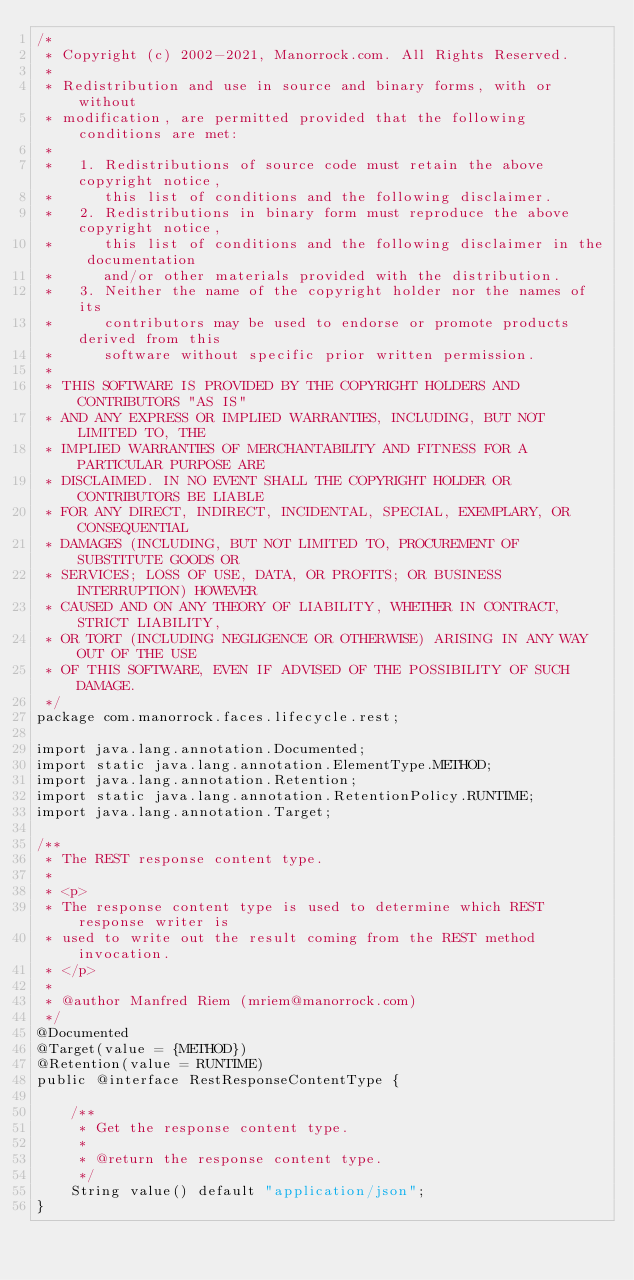<code> <loc_0><loc_0><loc_500><loc_500><_Java_>/*
 * Copyright (c) 2002-2021, Manorrock.com. All Rights Reserved.
 *
 * Redistribution and use in source and binary forms, with or without 
 * modification, are permitted provided that the following conditions are met:
 *
 *   1. Redistributions of source code must retain the above copyright notice, 
 *      this list of conditions and the following disclaimer.
 *   2. Redistributions in binary form must reproduce the above copyright notice,
 *      this list of conditions and the following disclaimer in the documentation
 *      and/or other materials provided with the distribution.
 *   3. Neither the name of the copyright holder nor the names of its 
 *      contributors may be used to endorse or promote products derived from this
 *      software without specific prior written permission.
 *
 * THIS SOFTWARE IS PROVIDED BY THE COPYRIGHT HOLDERS AND CONTRIBUTORS "AS IS" 
 * AND ANY EXPRESS OR IMPLIED WARRANTIES, INCLUDING, BUT NOT LIMITED TO, THE 
 * IMPLIED WARRANTIES OF MERCHANTABILITY AND FITNESS FOR A PARTICULAR PURPOSE ARE
 * DISCLAIMED. IN NO EVENT SHALL THE COPYRIGHT HOLDER OR CONTRIBUTORS BE LIABLE
 * FOR ANY DIRECT, INDIRECT, INCIDENTAL, SPECIAL, EXEMPLARY, OR CONSEQUENTIAL
 * DAMAGES (INCLUDING, BUT NOT LIMITED TO, PROCUREMENT OF SUBSTITUTE GOODS OR
 * SERVICES; LOSS OF USE, DATA, OR PROFITS; OR BUSINESS INTERRUPTION) HOWEVER
 * CAUSED AND ON ANY THEORY OF LIABILITY, WHETHER IN CONTRACT, STRICT LIABILITY,
 * OR TORT (INCLUDING NEGLIGENCE OR OTHERWISE) ARISING IN ANY WAY OUT OF THE USE
 * OF THIS SOFTWARE, EVEN IF ADVISED OF THE POSSIBILITY OF SUCH DAMAGE.
 */
package com.manorrock.faces.lifecycle.rest;

import java.lang.annotation.Documented;
import static java.lang.annotation.ElementType.METHOD;
import java.lang.annotation.Retention;
import static java.lang.annotation.RetentionPolicy.RUNTIME;
import java.lang.annotation.Target;

/**
 * The REST response content type.
 *
 * <p>
 * The response content type is used to determine which REST response writer is
 * used to write out the result coming from the REST method invocation.
 * </p>
 *
 * @author Manfred Riem (mriem@manorrock.com)
 */
@Documented
@Target(value = {METHOD})
@Retention(value = RUNTIME)
public @interface RestResponseContentType {

    /**
     * Get the response content type.
     *
     * @return the response content type.
     */
    String value() default "application/json";
}
</code> 